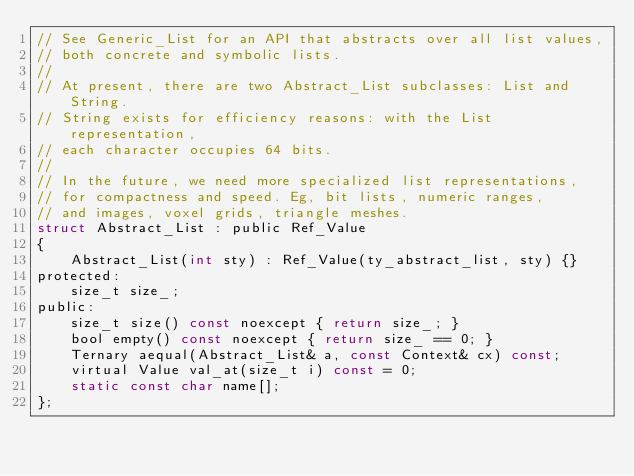<code> <loc_0><loc_0><loc_500><loc_500><_C_>// See Generic_List for an API that abstracts over all list values,
// both concrete and symbolic lists.
//
// At present, there are two Abstract_List subclasses: List and String.
// String exists for efficiency reasons: with the List representation,
// each character occupies 64 bits.
//
// In the future, we need more specialized list representations,
// for compactness and speed. Eg, bit lists, numeric ranges,
// and images, voxel grids, triangle meshes.
struct Abstract_List : public Ref_Value
{
    Abstract_List(int sty) : Ref_Value(ty_abstract_list, sty) {}
protected:
    size_t size_;
public:
    size_t size() const noexcept { return size_; }
    bool empty() const noexcept { return size_ == 0; }
    Ternary aequal(Abstract_List& a, const Context& cx) const;
    virtual Value val_at(size_t i) const = 0;
    static const char name[];
};
</code> 